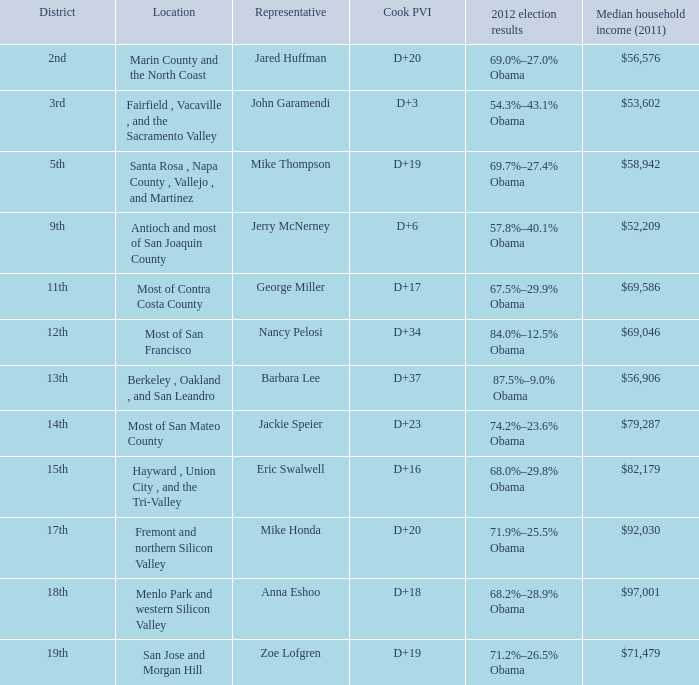What is the Cook PVI for the location that has a representative of Mike Thompson? D+19. 